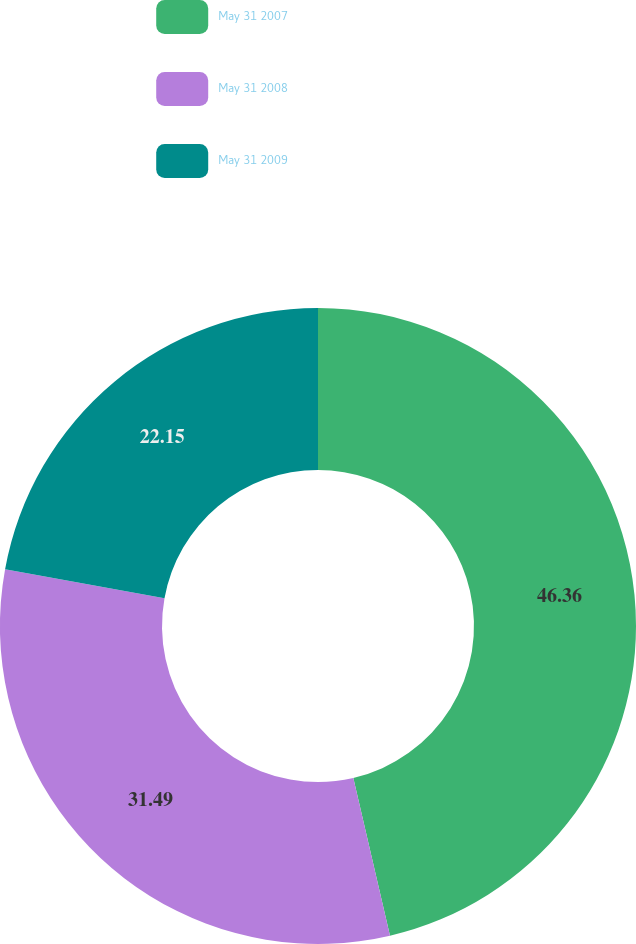<chart> <loc_0><loc_0><loc_500><loc_500><pie_chart><fcel>May 31 2007<fcel>May 31 2008<fcel>May 31 2009<nl><fcel>46.37%<fcel>31.49%<fcel>22.15%<nl></chart> 